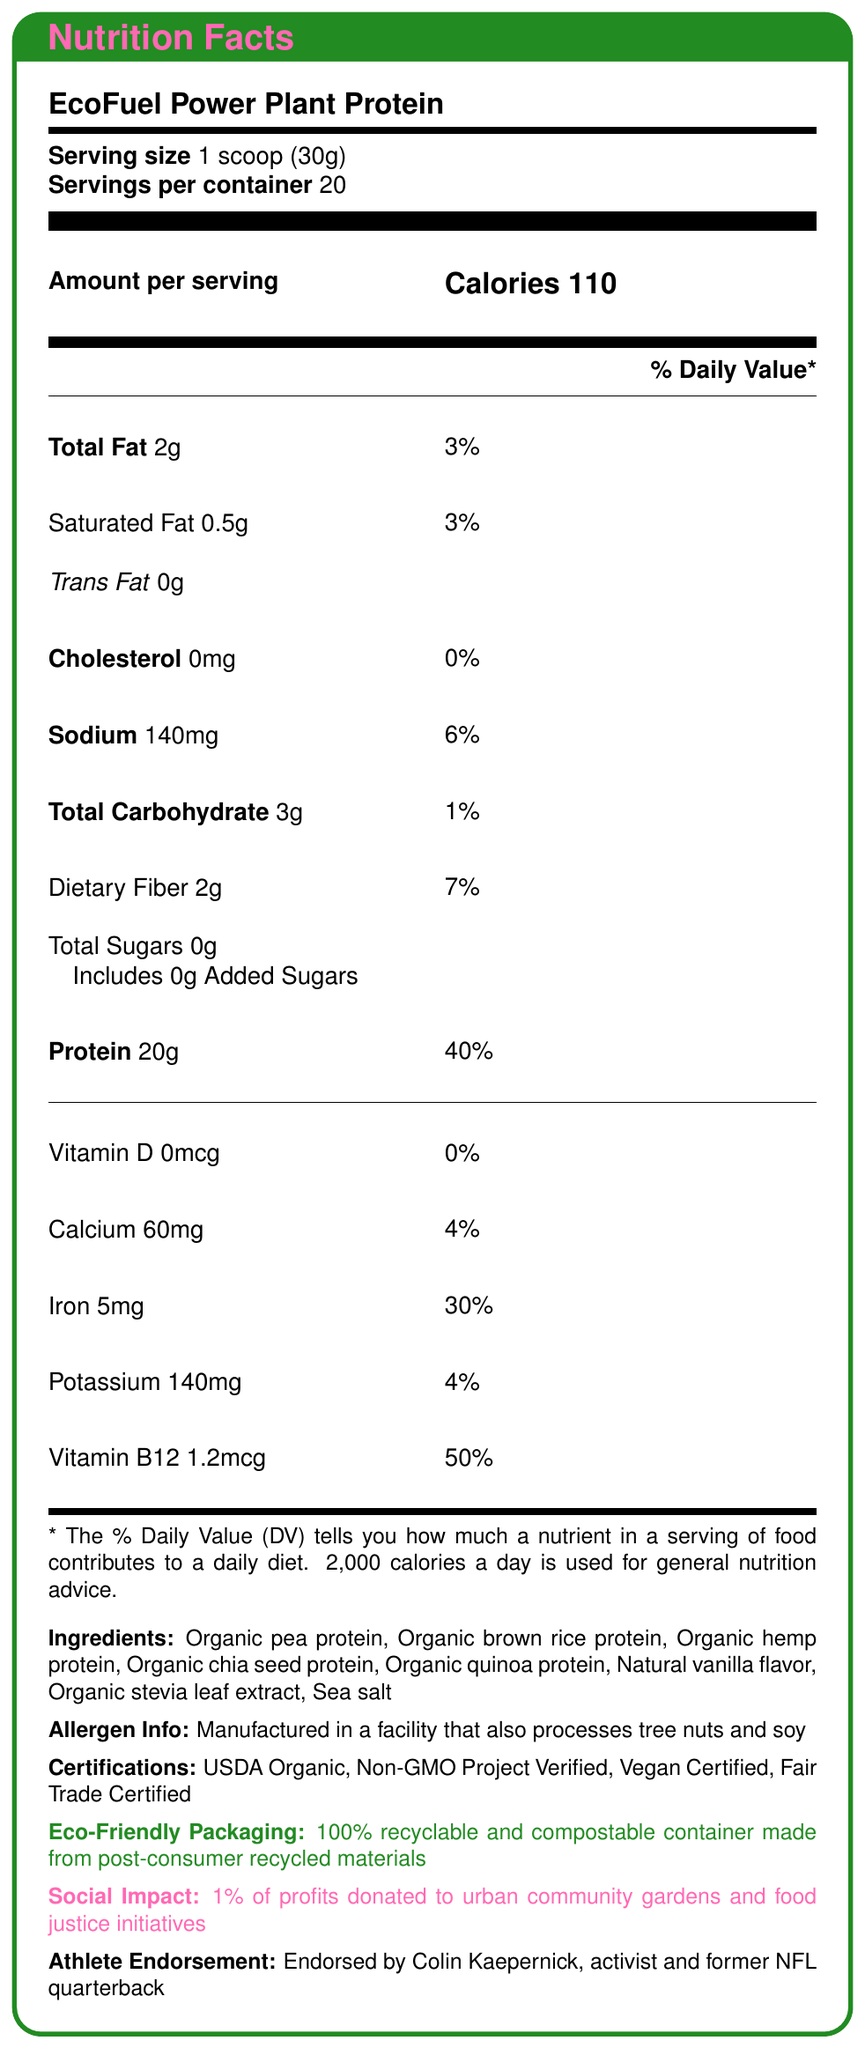what is the serving size of EcoFuel Power Plant Protein? The document states "Serving size: 1 scoop (30g)".
Answer: 1 scoop (30g) how many servings are there per container? The document lists "Servings per container: 20".
Answer: 20 how many grams of protein are in one serving? The document specifies "Protein: 20g per serving".
Answer: 20g what is the % Daily Value of iron per serving? The document shows "Iron 5mg" with "30%" daily value.
Answer: 30% which athlete endorses EcoFuel Power Plant Protein? The document includes "Endorsed by Colin Kaepernick, activist and former NFL quarterback".
Answer: Colin Kaepernick which certifications does this product have? A. USDA Organic B. Non-GMO Project Verified C. Vegan Certified D. All of the above The document lists the certifications as "USDA Organic, Non-GMO Project Verified, Vegan Certified, Fair Trade Certified".
Answer: D. All of the above how many calories are in one serving? The document mentions "Calories 110 per serving."
Answer: 110 what is the total fat content per serving? A. 1g B. 2g C. 3g D. 4g The document lists "Total Fat: 2g".
Answer: B. 2g is EcoFuel Power Plant Protein vegan certified? The document states "Vegan Certified" under certifications.
Answer: Yes describe the main idea of the document. Explanation: The document aims to inform potential consumers about the nutrition details, eco-friendliness, and social benefits of the product, promoting it as a healthy and responsible choice.
Answer: The document provides detailed nutrition facts for EcoFuel Power Plant Protein, including serving size, nutrient amounts, ingredients, allergen information, certifications, environmentally friendly packaging, social impact, and athlete endorsement by Colin Kaepernick. does the product contain any added sugars? The document specifies "Total Sugars 0g, Includes 0g Added Sugars".
Answer: No what materials are used for the product's packaging? The document notes "eco-friendly packaging: 100% recyclable and compostable container made from post-consumer recycled materials".
Answer: 100% recyclable and compostable container made from post-consumer recycled materials can the amount of total carbohydrates be determined per container? The document only provides the carbohydrate content per serving, not for the entire container.
Answer: Cannot be determined which ingredient is not included in EcoFuel Power Plant Protein? A. Organic pea protein B. Organic brown rice protein C. Organic stevia leaf extract D. Artificial sweeteners The ingredients listed are organic proteins, natural vanilla flavor, organic stevia leaf extract, and sea salt; no artificial sweeteners are mentioned.
Answer: D. Artificial sweeteners where are 1% of profits donated? The document states "1% of profits donated to urban community gardens and food justice initiatives".
Answer: Urban community gardens and food justice initiatives is the product free of trans fat? The document lists "Trans Fat: 0g".
Answer: Yes what is the % Daily Value of dietary fiber per serving? The document mentions "Dietary Fiber 2g" with "7%" daily value.
Answer: 7% how much sodium does one serving contain? The document specifies "Sodium: 140mg".
Answer: 140mg does the product provide any Vitamin D? The document lists "Vitamin D 0mcg" with "0%" daily value.
Answer: No what is the ingredient listed for flavoring? The document includes "Natural vanilla flavor" in the ingredients list.
Answer: Natural vanilla flavor 